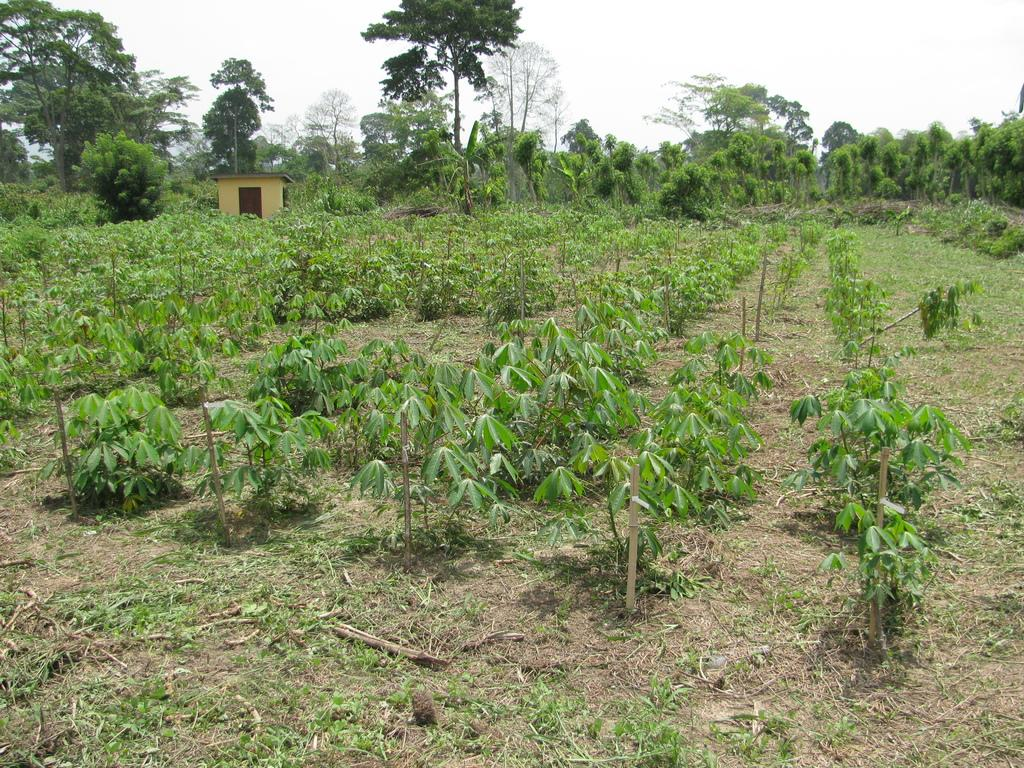What type of vegetation can be seen in the image? There are plants and trees in the image. What type of structure is visible in the image? There is a house in the image. What can be seen in the background of the image? The sky is visible in the background of the image. How many firemen are present in the image? There are no firemen present in the image. What is the nationality of the plants in the image? Plants do not have a nationality, as they are not living beings with citizenship. 